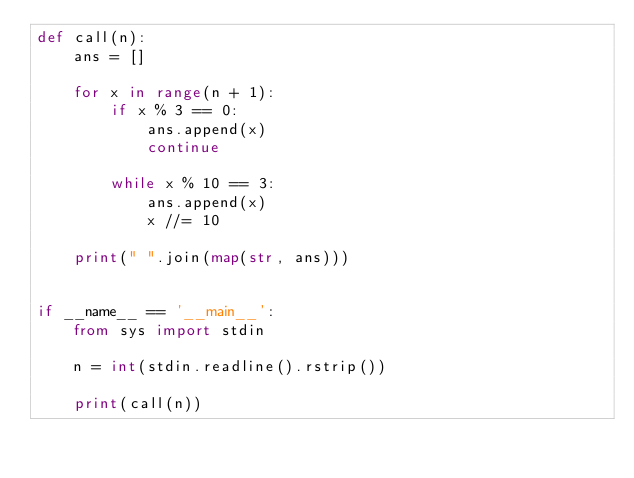<code> <loc_0><loc_0><loc_500><loc_500><_Python_>def call(n):
    ans = []

    for x in range(n + 1):
        if x % 3 == 0:
            ans.append(x)
            continue

        while x % 10 == 3:
            ans.append(x)
            x //= 10

    print(" ".join(map(str, ans)))


if __name__ == '__main__':
    from sys import stdin

    n = int(stdin.readline().rstrip())

    print(call(n))

</code> 